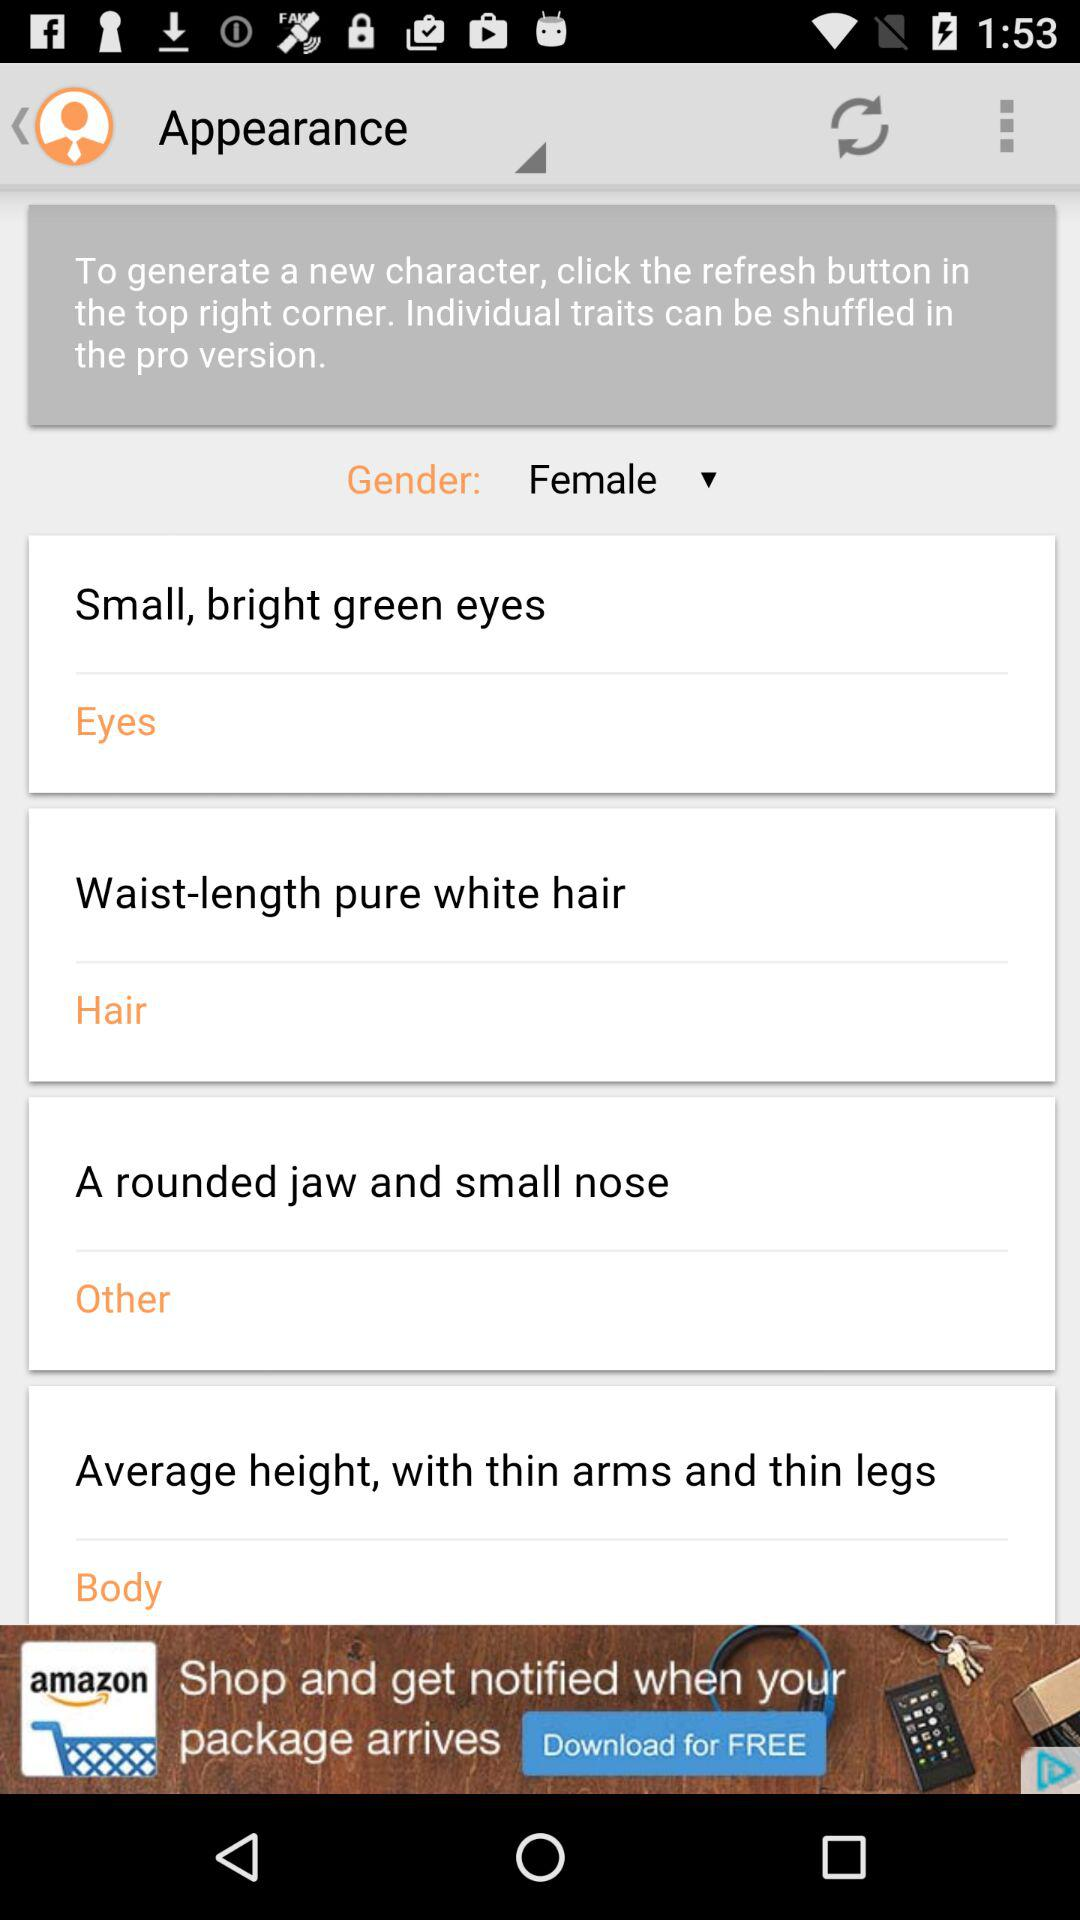Which gender is selected? The selected gender is female. 